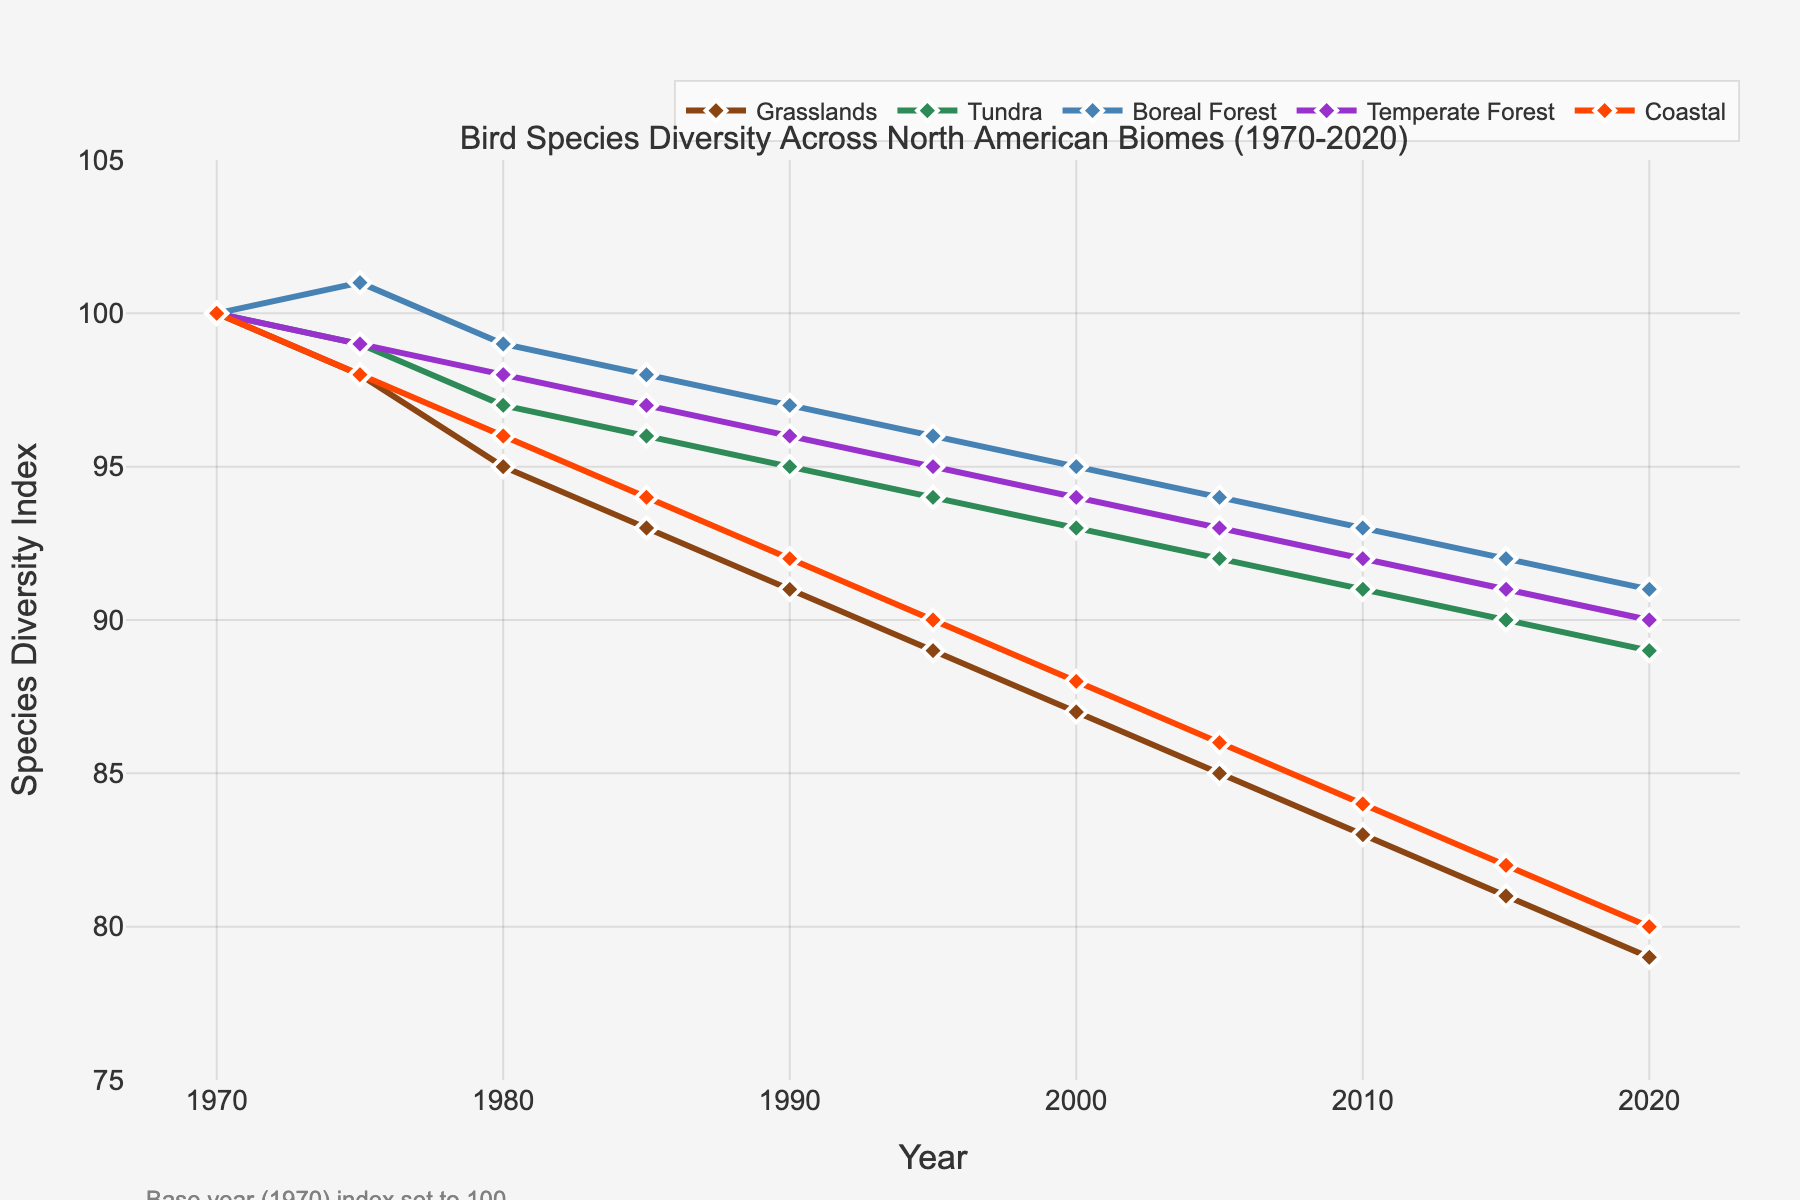Which biome shows the greatest decrease in bird species diversity from 1970 to 2020? Observe the start and end values for each biome's line on the plot. Grasslands start at 100 in 1970 and drop to 79 in 2020, a decrease of 21. This is the greatest decrease among the biomes.
Answer: Grasslands By how many points did the Tundra biome's species diversity index change between 1990 and 2020? Subtract the biodiversity index value for Tundra in 2020 from its value in 1990 (95 - 89).
Answer: 6 Which two biomes are closest in species diversity index around the year 2010? Compare the values for all biomes in 2010. Boreal Forest and Temperate Forest have the closest values (93 and 92 respectively).
Answer: Boreal Forest and Temperate Forest What trend do we see in the Coastal biome's species diversity index from 1970 to 2020? Observe the Coastal line on the plot, noting that it starts at 100 and decreases steadily to 80.
Answer: Decreasing Compare the total decrease in species diversity index for the Boreal Forest and Temperate Forest from 1970 to 2020. Which is greater? Subtract the 2020 index values from the 1970 values for both Boreal Forest (100 - 91 = 9) and Temperate Forest (100 - 90 = 10). Since 10 is greater than 9, the decrease is greater for Temperate Forest.
Answer: Temperate Forest What is the average species diversity index of the Boreal Forest across the years sampled? Add up all the Boreal Forest values and divide by the number of years: (100 + 101 + 99 + 98 + 97 + 96 + 95 + 94 + 93 + 92 + 91) / 11.
Answer: 96.5 In which decade did the Grasslands biome experience the sharpest decline? Observe the steepness of the Grasslands line per decade, noting the steepest decline between 1970 and 1980 (from 100 to 95, a change of 5 points).
Answer: 1970s Which biome has the least variance in species diversity index over the 50-year period? Compare the range of values for each biome; Tundra varies the least, from 100 to 89, a range of 11 points.
Answer: Tundra 